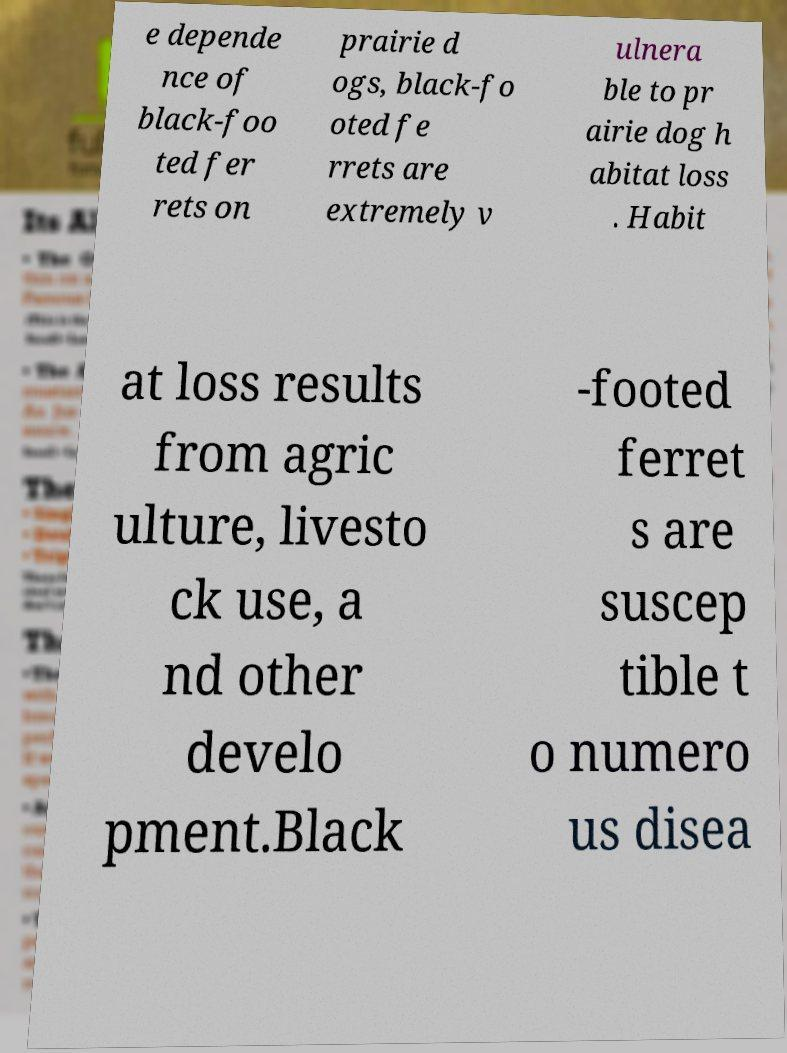I need the written content from this picture converted into text. Can you do that? e depende nce of black-foo ted fer rets on prairie d ogs, black-fo oted fe rrets are extremely v ulnera ble to pr airie dog h abitat loss . Habit at loss results from agric ulture, livesto ck use, a nd other develo pment.Black -footed ferret s are suscep tible t o numero us disea 